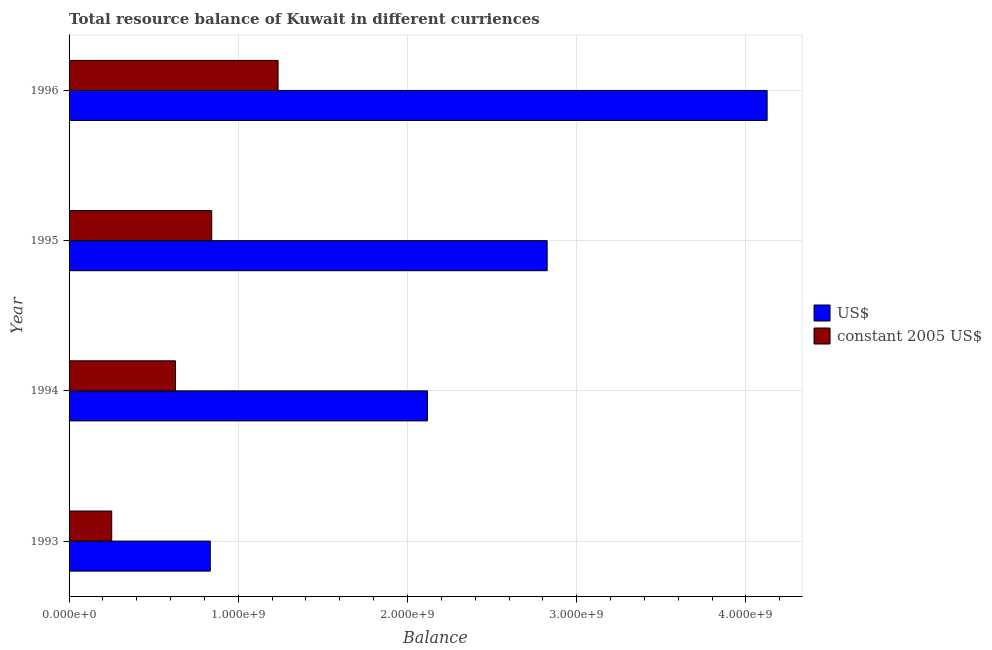How many different coloured bars are there?
Provide a short and direct response. 2. Are the number of bars per tick equal to the number of legend labels?
Offer a very short reply. Yes. How many bars are there on the 1st tick from the bottom?
Your answer should be very brief. 2. What is the resource balance in us$ in 1996?
Your response must be concise. 4.12e+09. Across all years, what is the maximum resource balance in us$?
Your answer should be compact. 4.12e+09. Across all years, what is the minimum resource balance in constant us$?
Keep it short and to the point. 2.52e+08. In which year was the resource balance in us$ maximum?
Provide a short and direct response. 1996. In which year was the resource balance in constant us$ minimum?
Your answer should be compact. 1993. What is the total resource balance in us$ in the graph?
Provide a short and direct response. 9.90e+09. What is the difference between the resource balance in us$ in 1995 and that in 1996?
Offer a very short reply. -1.30e+09. What is the difference between the resource balance in constant us$ in 1995 and the resource balance in us$ in 1993?
Your response must be concise. 8.56e+06. What is the average resource balance in constant us$ per year?
Your answer should be very brief. 7.40e+08. In the year 1996, what is the difference between the resource balance in constant us$ and resource balance in us$?
Provide a short and direct response. -2.89e+09. What is the ratio of the resource balance in constant us$ in 1994 to that in 1995?
Offer a very short reply. 0.75. Is the resource balance in us$ in 1994 less than that in 1996?
Give a very brief answer. Yes. What is the difference between the highest and the second highest resource balance in constant us$?
Ensure brevity in your answer.  3.92e+08. What is the difference between the highest and the lowest resource balance in constant us$?
Keep it short and to the point. 9.83e+08. In how many years, is the resource balance in us$ greater than the average resource balance in us$ taken over all years?
Provide a succinct answer. 2. Is the sum of the resource balance in us$ in 1995 and 1996 greater than the maximum resource balance in constant us$ across all years?
Keep it short and to the point. Yes. What does the 2nd bar from the top in 1993 represents?
Offer a terse response. US$. What does the 2nd bar from the bottom in 1995 represents?
Keep it short and to the point. Constant 2005 us$. How many bars are there?
Keep it short and to the point. 8. Does the graph contain any zero values?
Your answer should be compact. No. Does the graph contain grids?
Make the answer very short. Yes. How many legend labels are there?
Your answer should be very brief. 2. What is the title of the graph?
Give a very brief answer. Total resource balance of Kuwait in different curriences. Does "Primary school" appear as one of the legend labels in the graph?
Make the answer very short. No. What is the label or title of the X-axis?
Your response must be concise. Balance. What is the label or title of the Y-axis?
Give a very brief answer. Year. What is the Balance in US$ in 1993?
Provide a short and direct response. 8.34e+08. What is the Balance in constant 2005 US$ in 1993?
Your response must be concise. 2.52e+08. What is the Balance in US$ in 1994?
Offer a very short reply. 2.12e+09. What is the Balance of constant 2005 US$ in 1994?
Your answer should be very brief. 6.29e+08. What is the Balance of US$ in 1995?
Your answer should be compact. 2.83e+09. What is the Balance in constant 2005 US$ in 1995?
Provide a succinct answer. 8.43e+08. What is the Balance of US$ in 1996?
Your answer should be compact. 4.12e+09. What is the Balance in constant 2005 US$ in 1996?
Make the answer very short. 1.23e+09. Across all years, what is the maximum Balance of US$?
Make the answer very short. 4.12e+09. Across all years, what is the maximum Balance in constant 2005 US$?
Provide a short and direct response. 1.23e+09. Across all years, what is the minimum Balance in US$?
Make the answer very short. 8.34e+08. Across all years, what is the minimum Balance in constant 2005 US$?
Your answer should be very brief. 2.52e+08. What is the total Balance of US$ in the graph?
Provide a short and direct response. 9.90e+09. What is the total Balance in constant 2005 US$ in the graph?
Provide a succinct answer. 2.96e+09. What is the difference between the Balance in US$ in 1993 and that in 1994?
Offer a terse response. -1.28e+09. What is the difference between the Balance in constant 2005 US$ in 1993 and that in 1994?
Keep it short and to the point. -3.77e+08. What is the difference between the Balance of US$ in 1993 and that in 1995?
Provide a short and direct response. -1.99e+09. What is the difference between the Balance in constant 2005 US$ in 1993 and that in 1995?
Ensure brevity in your answer.  -5.91e+08. What is the difference between the Balance in US$ in 1993 and that in 1996?
Offer a terse response. -3.29e+09. What is the difference between the Balance in constant 2005 US$ in 1993 and that in 1996?
Keep it short and to the point. -9.83e+08. What is the difference between the Balance of US$ in 1994 and that in 1995?
Your response must be concise. -7.07e+08. What is the difference between the Balance of constant 2005 US$ in 1994 and that in 1995?
Offer a terse response. -2.14e+08. What is the difference between the Balance of US$ in 1994 and that in 1996?
Your answer should be compact. -2.01e+09. What is the difference between the Balance of constant 2005 US$ in 1994 and that in 1996?
Your answer should be very brief. -6.06e+08. What is the difference between the Balance in US$ in 1995 and that in 1996?
Give a very brief answer. -1.30e+09. What is the difference between the Balance in constant 2005 US$ in 1995 and that in 1996?
Your answer should be very brief. -3.92e+08. What is the difference between the Balance in US$ in 1993 and the Balance in constant 2005 US$ in 1994?
Offer a terse response. 2.05e+08. What is the difference between the Balance in US$ in 1993 and the Balance in constant 2005 US$ in 1995?
Your answer should be compact. -8.56e+06. What is the difference between the Balance of US$ in 1993 and the Balance of constant 2005 US$ in 1996?
Your answer should be very brief. -4.01e+08. What is the difference between the Balance of US$ in 1994 and the Balance of constant 2005 US$ in 1995?
Your answer should be compact. 1.27e+09. What is the difference between the Balance of US$ in 1994 and the Balance of constant 2005 US$ in 1996?
Ensure brevity in your answer.  8.83e+08. What is the difference between the Balance of US$ in 1995 and the Balance of constant 2005 US$ in 1996?
Offer a very short reply. 1.59e+09. What is the average Balance in US$ per year?
Make the answer very short. 2.48e+09. What is the average Balance of constant 2005 US$ per year?
Ensure brevity in your answer.  7.40e+08. In the year 1993, what is the difference between the Balance of US$ and Balance of constant 2005 US$?
Your response must be concise. 5.82e+08. In the year 1994, what is the difference between the Balance in US$ and Balance in constant 2005 US$?
Your answer should be compact. 1.49e+09. In the year 1995, what is the difference between the Balance in US$ and Balance in constant 2005 US$?
Offer a terse response. 1.98e+09. In the year 1996, what is the difference between the Balance of US$ and Balance of constant 2005 US$?
Offer a terse response. 2.89e+09. What is the ratio of the Balance of US$ in 1993 to that in 1994?
Offer a terse response. 0.39. What is the ratio of the Balance in constant 2005 US$ in 1993 to that in 1994?
Provide a short and direct response. 0.4. What is the ratio of the Balance of US$ in 1993 to that in 1995?
Provide a succinct answer. 0.3. What is the ratio of the Balance in constant 2005 US$ in 1993 to that in 1995?
Offer a very short reply. 0.3. What is the ratio of the Balance of US$ in 1993 to that in 1996?
Offer a terse response. 0.2. What is the ratio of the Balance in constant 2005 US$ in 1993 to that in 1996?
Provide a short and direct response. 0.2. What is the ratio of the Balance in US$ in 1994 to that in 1995?
Your answer should be very brief. 0.75. What is the ratio of the Balance in constant 2005 US$ in 1994 to that in 1995?
Make the answer very short. 0.75. What is the ratio of the Balance in US$ in 1994 to that in 1996?
Your answer should be very brief. 0.51. What is the ratio of the Balance of constant 2005 US$ in 1994 to that in 1996?
Give a very brief answer. 0.51. What is the ratio of the Balance of US$ in 1995 to that in 1996?
Your answer should be very brief. 0.68. What is the ratio of the Balance in constant 2005 US$ in 1995 to that in 1996?
Provide a succinct answer. 0.68. What is the difference between the highest and the second highest Balance of US$?
Your answer should be compact. 1.30e+09. What is the difference between the highest and the second highest Balance of constant 2005 US$?
Ensure brevity in your answer.  3.92e+08. What is the difference between the highest and the lowest Balance of US$?
Make the answer very short. 3.29e+09. What is the difference between the highest and the lowest Balance in constant 2005 US$?
Keep it short and to the point. 9.83e+08. 